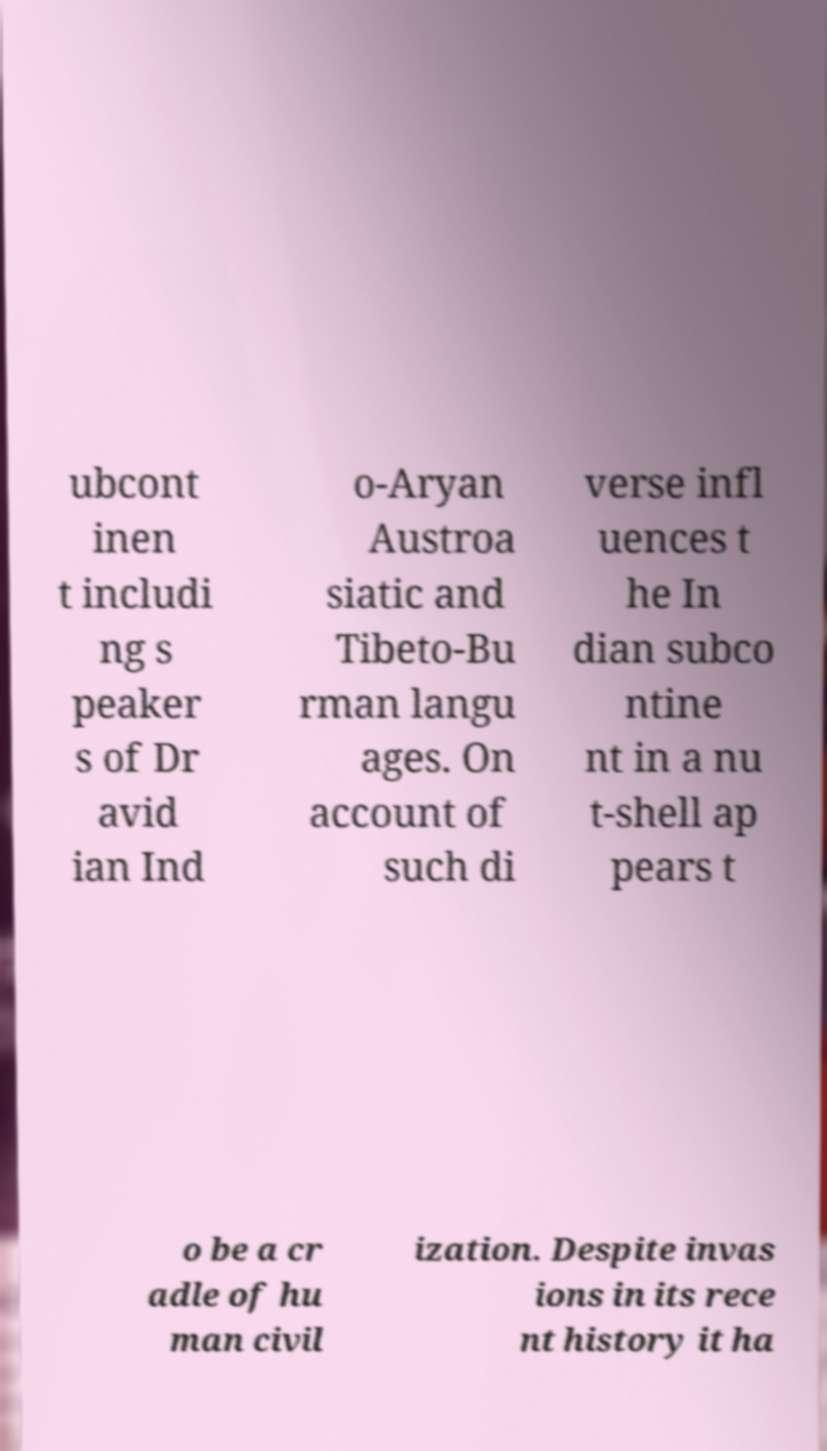Could you assist in decoding the text presented in this image and type it out clearly? ubcont inen t includi ng s peaker s of Dr avid ian Ind o-Aryan Austroa siatic and Tibeto-Bu rman langu ages. On account of such di verse infl uences t he In dian subco ntine nt in a nu t-shell ap pears t o be a cr adle of hu man civil ization. Despite invas ions in its rece nt history it ha 